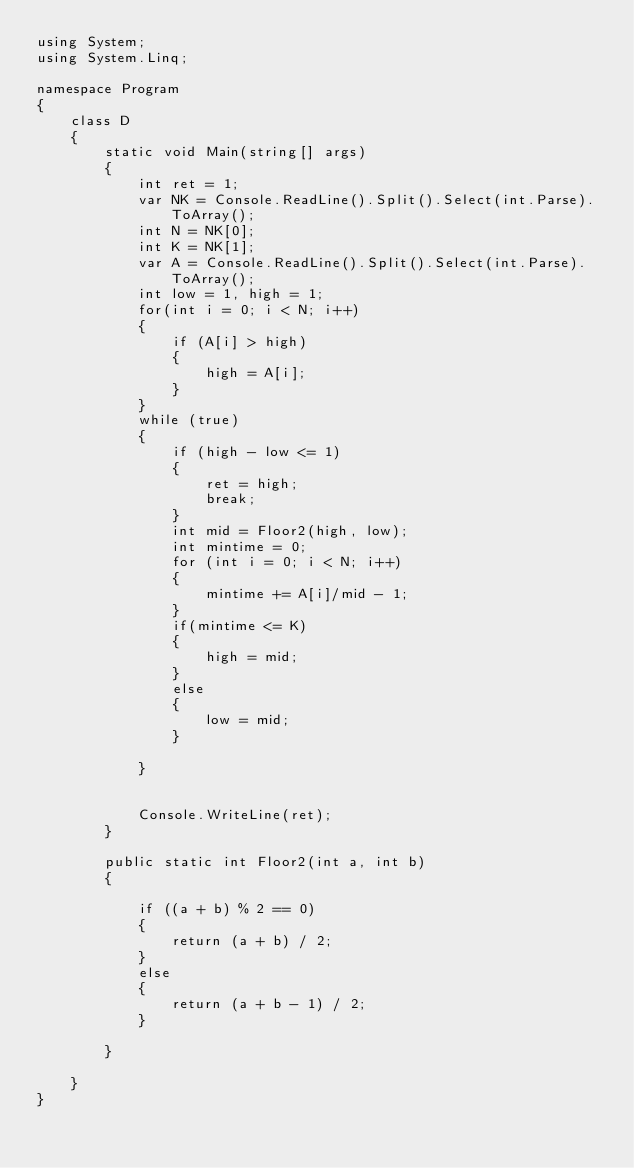<code> <loc_0><loc_0><loc_500><loc_500><_C#_>using System;
using System.Linq;

namespace Program
{
    class D
    {
        static void Main(string[] args)
        {
            int ret = 1;
            var NK = Console.ReadLine().Split().Select(int.Parse).ToArray();
            int N = NK[0];
            int K = NK[1];
            var A = Console.ReadLine().Split().Select(int.Parse).ToArray();
            int low = 1, high = 1;
            for(int i = 0; i < N; i++)
            {
                if (A[i] > high)
                {
                    high = A[i];
                }
            }
            while (true)
            {
                if (high - low <= 1)
                {
                    ret = high;
                    break;
                }
                int mid = Floor2(high, low);
                int mintime = 0;
                for (int i = 0; i < N; i++)
                {
                    mintime += A[i]/mid - 1;
                }
                if(mintime <= K)
                {
                    high = mid;
                }
                else
                {
                    low = mid;
                }
                
            }


            Console.WriteLine(ret);
        }

        public static int Floor2(int a, int b)
        {

            if ((a + b) % 2 == 0)
            {
                return (a + b) / 2;
            }
            else
            {
                return (a + b - 1) / 2;
            }

        }

    }
}
</code> 